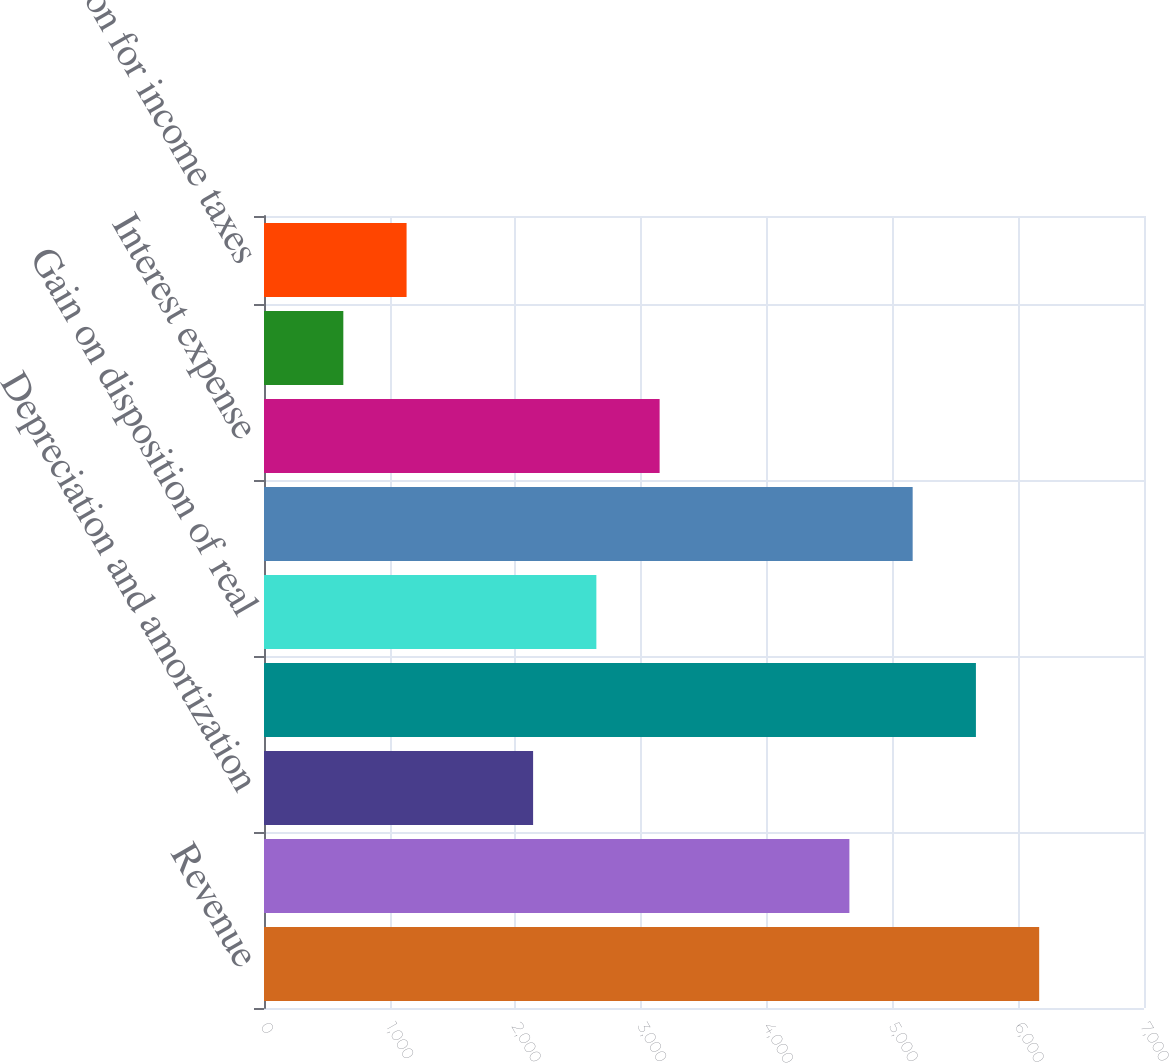Convert chart. <chart><loc_0><loc_0><loc_500><loc_500><bar_chart><fcel>Revenue<fcel>Operating administrative and<fcel>Depreciation and amortization<fcel>Total costs and expenses<fcel>Gain on disposition of real<fcel>Operating income<fcel>Interest expense<fcel>Income from discontinued<fcel>Provision for income taxes<nl><fcel>6166.2<fcel>4656.6<fcel>2140.6<fcel>5663<fcel>2643.8<fcel>5159.8<fcel>3147<fcel>631<fcel>1134.2<nl></chart> 